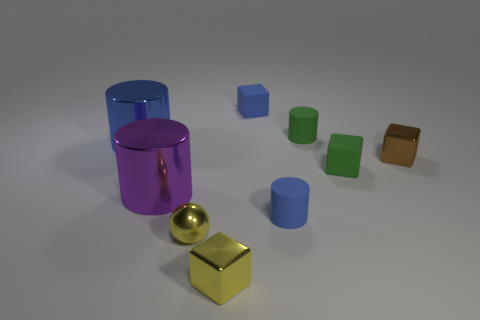Are there any yellow cubes that have the same size as the purple metal thing?
Your answer should be compact. No. What size is the blue object on the left side of the tiny blue matte thing that is left of the small blue matte cylinder?
Your response must be concise. Large. What number of blocks are the same color as the ball?
Offer a terse response. 1. There is a tiny blue rubber thing that is in front of the tiny green rubber thing that is behind the blue metallic thing; what shape is it?
Offer a very short reply. Cylinder. What number of small purple cylinders are made of the same material as the green cube?
Offer a terse response. 0. There is a tiny yellow object that is on the right side of the tiny yellow metallic ball; what is it made of?
Offer a terse response. Metal. What is the shape of the tiny yellow metal thing on the right side of the tiny yellow metallic sphere right of the large metal thing that is on the right side of the big blue metal thing?
Offer a terse response. Cube. Is the color of the small cylinder on the left side of the green rubber cylinder the same as the tiny rubber cube that is to the left of the small green cylinder?
Offer a terse response. Yes. Are there fewer brown shiny objects that are to the right of the brown cube than small green rubber blocks that are behind the small yellow cube?
Provide a short and direct response. Yes. There is another big metal object that is the same shape as the big blue object; what is its color?
Ensure brevity in your answer.  Purple. 